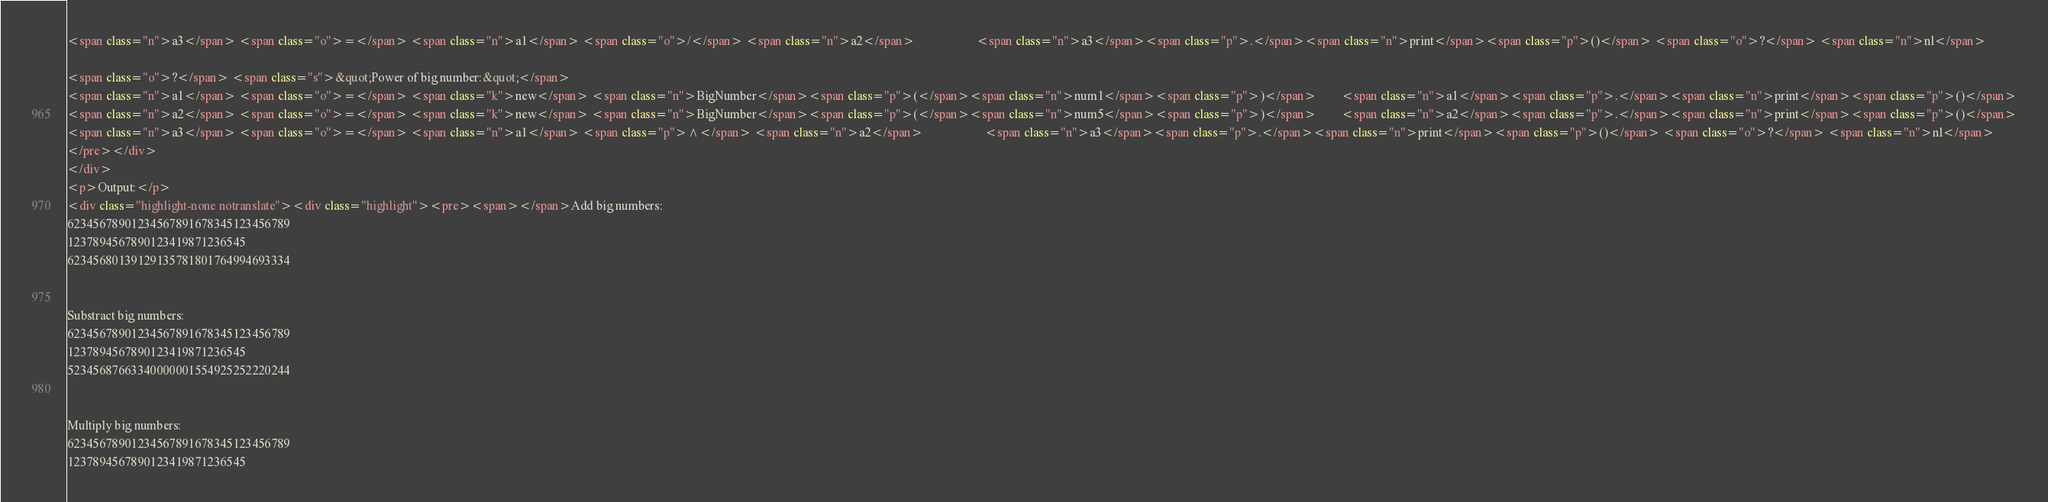Convert code to text. <code><loc_0><loc_0><loc_500><loc_500><_HTML_><span class="n">a3</span> <span class="o">=</span> <span class="n">a1</span> <span class="o">/</span> <span class="n">a2</span>                    <span class="n">a3</span><span class="p">.</span><span class="n">print</span><span class="p">()</span> <span class="o">?</span> <span class="n">nl</span>

<span class="o">?</span> <span class="s">&quot;Power of big number:&quot;</span>
<span class="n">a1</span> <span class="o">=</span> <span class="k">new</span> <span class="n">BigNumber</span><span class="p">(</span><span class="n">num1</span><span class="p">)</span>        <span class="n">a1</span><span class="p">.</span><span class="n">print</span><span class="p">()</span>
<span class="n">a2</span> <span class="o">=</span> <span class="k">new</span> <span class="n">BigNumber</span><span class="p">(</span><span class="n">num5</span><span class="p">)</span>        <span class="n">a2</span><span class="p">.</span><span class="n">print</span><span class="p">()</span>
<span class="n">a3</span> <span class="o">=</span> <span class="n">a1</span> <span class="p">^</span> <span class="n">a2</span>                    <span class="n">a3</span><span class="p">.</span><span class="n">print</span><span class="p">()</span> <span class="o">?</span> <span class="n">nl</span>
</pre></div>
</div>
<p>Output:</p>
<div class="highlight-none notranslate"><div class="highlight"><pre><span></span>Add big numbers:
62345678901234567891678345123456789
1237894567890123419871236545
62345680139129135781801764994693334


Substract big numbers:
62345678901234567891678345123456789
1237894567890123419871236545
52345687663340000001554925252220244


Multiply big numbers:
62345678901234567891678345123456789
1237894567890123419871236545</code> 